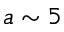<formula> <loc_0><loc_0><loc_500><loc_500>a \sim 5</formula> 